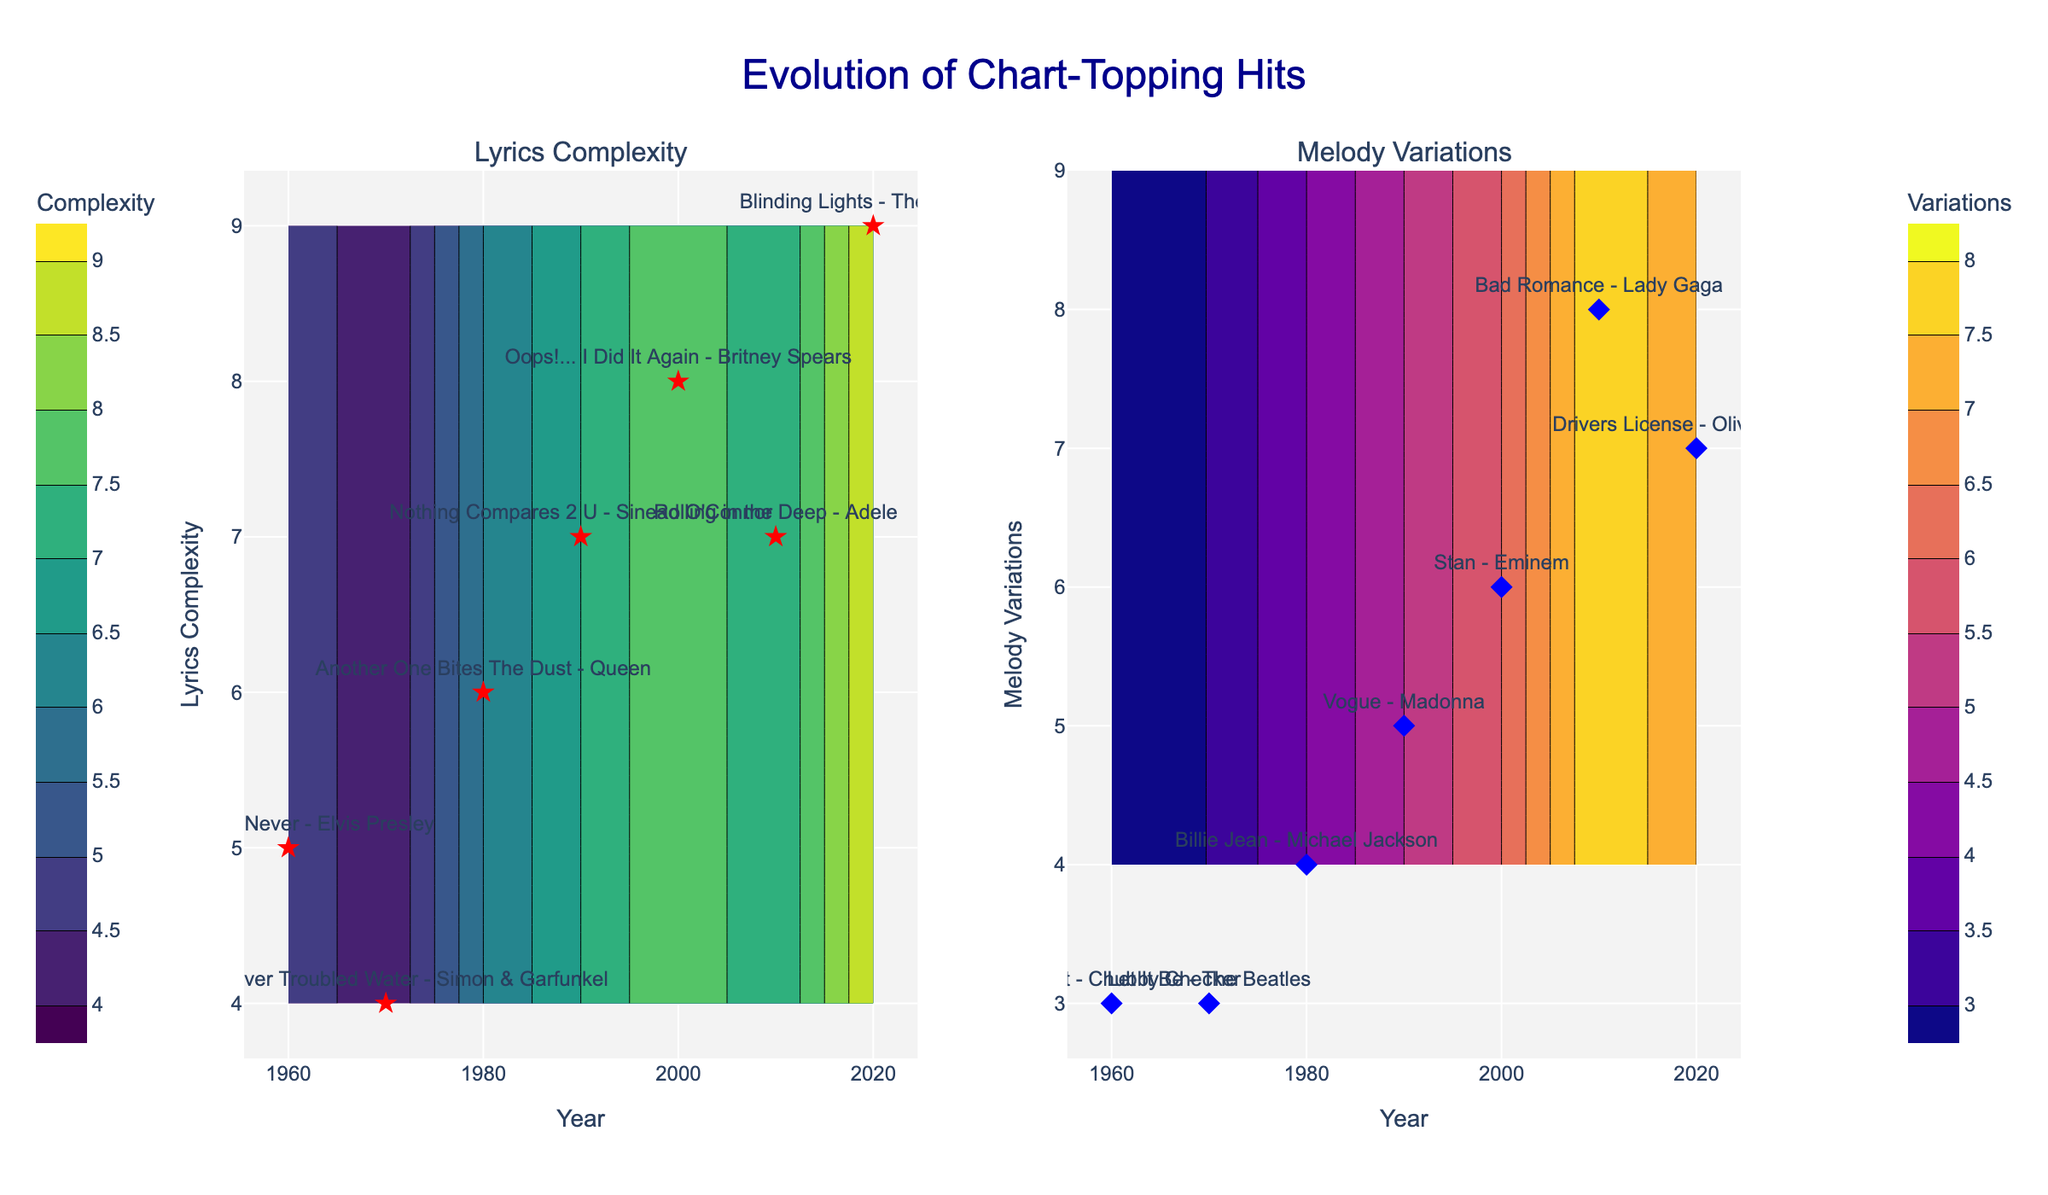What is the title of the plot? The title of the plot is centered at the top and is written in large, dark blue font. Read the title directly from the plot.
Answer: Evolution of Chart-Topping Hits Which axis represents the years in the contour plots? Both contour plots have a horizontal axis labeled "Year". This year axis spans across all decades shown in the dataset.
Answer: The x-axis What is the color scale used in the lyrics complexity contour plot? The left contour plot uses a color scale that ranges from a set of colors; the specific colors are typical of the 'Viridis' palette.
Answer: Viridis Identify one song associated with lyrics complexity in the 1980s. Look for the star markers along the 1980s section of the lyrics complexity contour plot and read the song label next to it.
Answer: Another One Bites The Dust - Queen What is the range of melody variations shown in the plot? The melody variations range from the minimum value observed to the maximum value observed in the dataset. Check the y-axis labels on the right contour plot.
Answer: 3 to 8 How does lyrics complexity in the 2000s compare to that in the 1970s? Compare the positions of the star markers for the 2000 and 1970 decades on the lyrics complexity contour plot (left).
Answer: Higher in the 2000s Which decade has the highest lyrics complexity? Look at the contour plot on the left and identify the decade with the highest position of the star markers.
Answer: 2020s Which song in the 2010s has the highest melody variations? Look in the 2010s section of the melody variations contour plot (right) and identify the song label with the highest value.
Answer: Bad Romance - Lady Gaga What is the trend in melody variations from the 1960s to the 2010s? Observe the general movement of the markers in the melody variations contour plot from left to right.
Answer: Increasing How has the range of lyrics complexity evolved over the decades? Observe the spread of the star markers along the y-axis in the lyrics complexity plot. Compare how it varies from the 1960s through to the 2020s.
Answer: It has broadened 